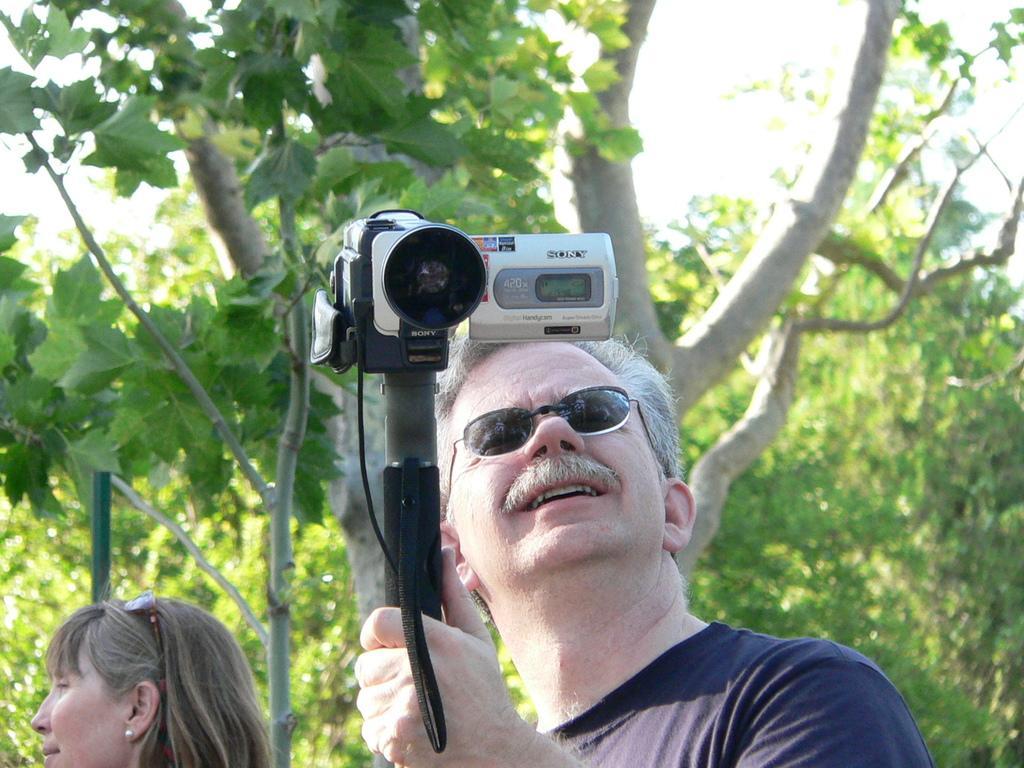In one or two sentences, can you explain what this image depicts? In this image I see a man who is holding a camera and I see a woman over here. In the background I see the trees. 